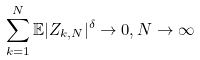<formula> <loc_0><loc_0><loc_500><loc_500>\sum _ { k = 1 } ^ { N } \mathbb { E } | Z _ { k , N } | ^ { \delta } \to 0 , N \to \infty</formula> 